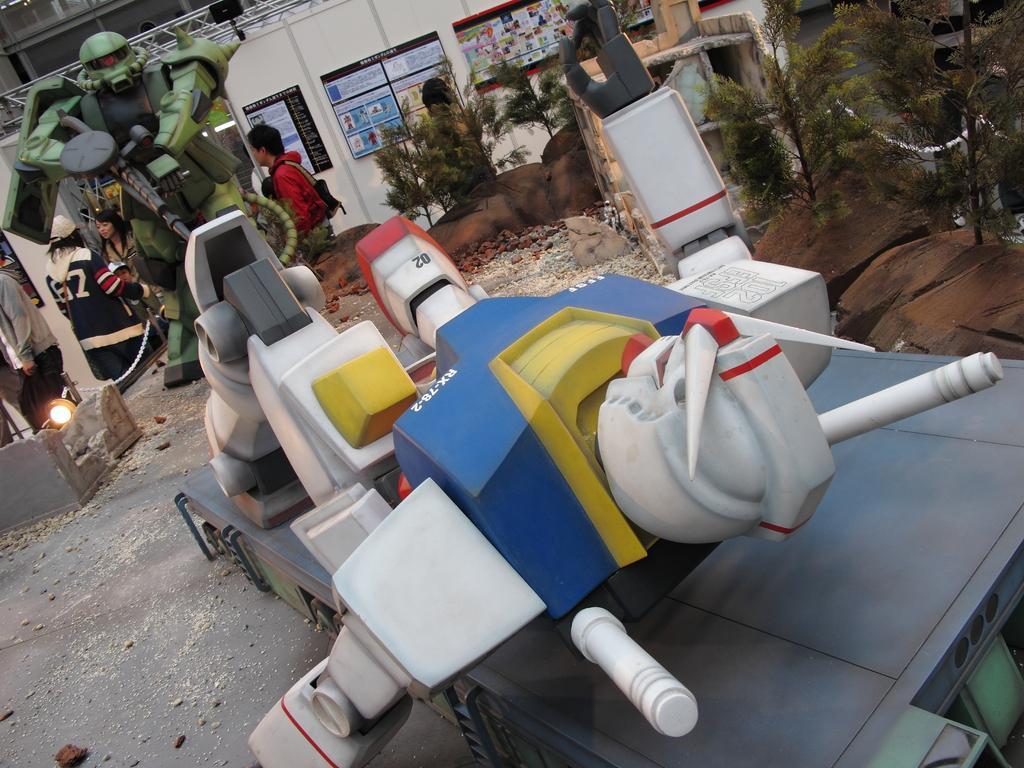Could you give a brief overview of what you see in this image? In the image there is some machine in the foreground and behind that there is some object, behind that object there are few people, in the background there is a wall and in front of the wall there are some posters, on the right side there are plants. 